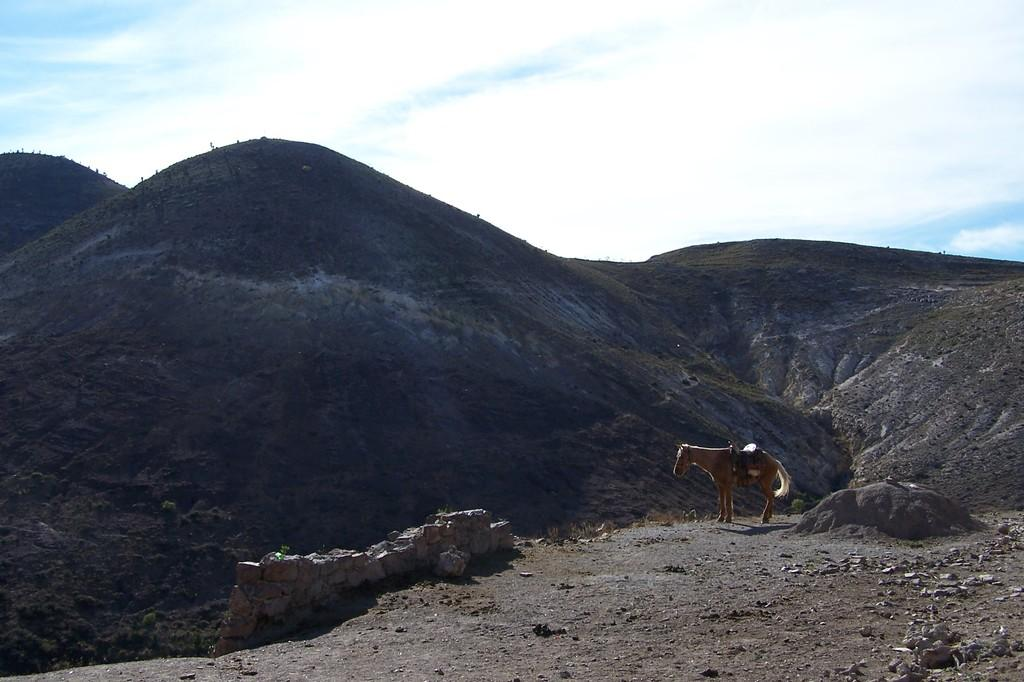What animal is on the ground in the image? There is a horse on the ground in the image. What type of natural elements can be seen in the image? Stones and rocks are visible in the image. What type of vegetation is visible on the hills in the image? There is a group of trees on the hills in the image. What is the condition of the sky in the image? The sky is visible in the image and appears cloudy. Reasoning: Let's think step by step by step in order to produce the conversation. We start by identifying the main subject in the image, which is the horse on the ground. Then, we expand the conversation to include other elements that are also visible, such as stones, rocks, trees, and the sky. Each question is designed to elicit a specific detail about the image that is known from the provided facts. Absurd Question/Answer: What type of punishment is being administered to the horse in the image? There is no indication of punishment in the image; the horse is simply standing on the ground. Can you tell me how many cannons are present in the image? There are no cannons present in the image. What type of punishment is being administered to the horse in the image? There is no indication of punishment in the image; the horse is simply standing on the ground. Can you tell me how many cannons are present in the image? There are no cannons present in the image. 